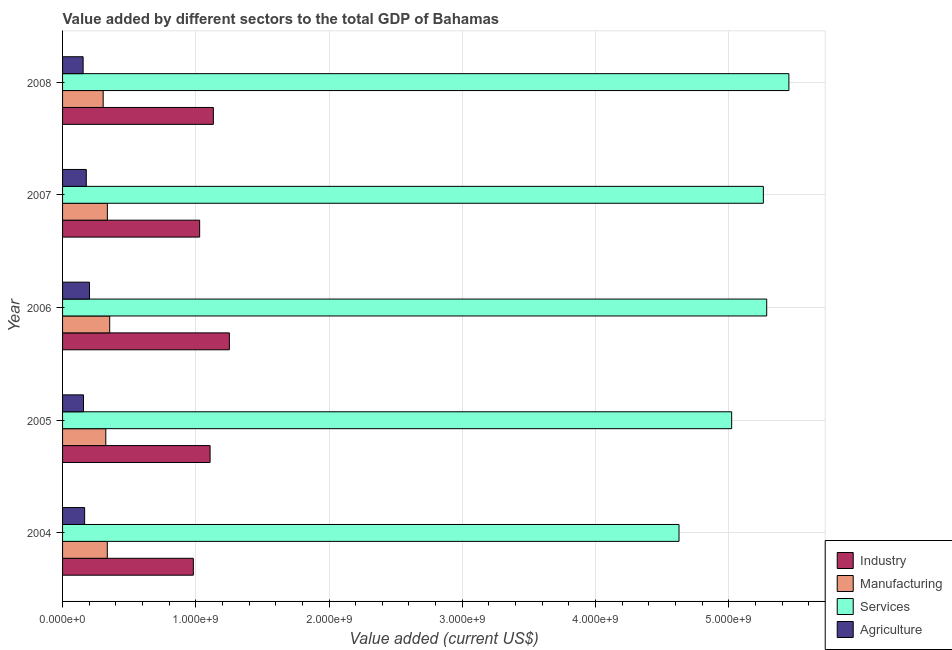How many groups of bars are there?
Your answer should be compact. 5. Are the number of bars per tick equal to the number of legend labels?
Provide a short and direct response. Yes. Are the number of bars on each tick of the Y-axis equal?
Offer a terse response. Yes. How many bars are there on the 3rd tick from the bottom?
Your answer should be very brief. 4. What is the label of the 2nd group of bars from the top?
Keep it short and to the point. 2007. In how many cases, is the number of bars for a given year not equal to the number of legend labels?
Give a very brief answer. 0. What is the value added by industrial sector in 2006?
Provide a succinct answer. 1.25e+09. Across all years, what is the maximum value added by industrial sector?
Your answer should be very brief. 1.25e+09. Across all years, what is the minimum value added by industrial sector?
Give a very brief answer. 9.82e+08. What is the total value added by manufacturing sector in the graph?
Provide a short and direct response. 1.66e+09. What is the difference between the value added by services sector in 2006 and that in 2008?
Keep it short and to the point. -1.67e+08. What is the difference between the value added by agricultural sector in 2004 and the value added by industrial sector in 2007?
Your answer should be very brief. -8.63e+08. What is the average value added by manufacturing sector per year?
Your response must be concise. 3.31e+08. In the year 2005, what is the difference between the value added by services sector and value added by manufacturing sector?
Your response must be concise. 4.70e+09. Is the difference between the value added by manufacturing sector in 2004 and 2008 greater than the difference between the value added by agricultural sector in 2004 and 2008?
Your answer should be very brief. Yes. What is the difference between the highest and the second highest value added by services sector?
Make the answer very short. 1.67e+08. What is the difference between the highest and the lowest value added by manufacturing sector?
Your answer should be very brief. 4.90e+07. Is the sum of the value added by manufacturing sector in 2005 and 2007 greater than the maximum value added by agricultural sector across all years?
Offer a terse response. Yes. What does the 2nd bar from the top in 2004 represents?
Give a very brief answer. Services. What does the 2nd bar from the bottom in 2004 represents?
Your answer should be compact. Manufacturing. Is it the case that in every year, the sum of the value added by industrial sector and value added by manufacturing sector is greater than the value added by services sector?
Offer a very short reply. No. Are the values on the major ticks of X-axis written in scientific E-notation?
Give a very brief answer. Yes. Does the graph contain grids?
Your answer should be compact. Yes. How many legend labels are there?
Give a very brief answer. 4. What is the title of the graph?
Provide a succinct answer. Value added by different sectors to the total GDP of Bahamas. What is the label or title of the X-axis?
Ensure brevity in your answer.  Value added (current US$). What is the label or title of the Y-axis?
Your answer should be compact. Year. What is the Value added (current US$) of Industry in 2004?
Provide a succinct answer. 9.82e+08. What is the Value added (current US$) in Manufacturing in 2004?
Your response must be concise. 3.36e+08. What is the Value added (current US$) of Services in 2004?
Ensure brevity in your answer.  4.63e+09. What is the Value added (current US$) in Agriculture in 2004?
Give a very brief answer. 1.66e+08. What is the Value added (current US$) of Industry in 2005?
Ensure brevity in your answer.  1.11e+09. What is the Value added (current US$) in Manufacturing in 2005?
Offer a very short reply. 3.25e+08. What is the Value added (current US$) of Services in 2005?
Your answer should be compact. 5.02e+09. What is the Value added (current US$) of Agriculture in 2005?
Your response must be concise. 1.57e+08. What is the Value added (current US$) of Industry in 2006?
Keep it short and to the point. 1.25e+09. What is the Value added (current US$) in Manufacturing in 2006?
Your response must be concise. 3.54e+08. What is the Value added (current US$) in Services in 2006?
Ensure brevity in your answer.  5.28e+09. What is the Value added (current US$) in Agriculture in 2006?
Provide a succinct answer. 2.02e+08. What is the Value added (current US$) of Industry in 2007?
Give a very brief answer. 1.03e+09. What is the Value added (current US$) of Manufacturing in 2007?
Keep it short and to the point. 3.36e+08. What is the Value added (current US$) in Services in 2007?
Provide a succinct answer. 5.26e+09. What is the Value added (current US$) in Agriculture in 2007?
Give a very brief answer. 1.78e+08. What is the Value added (current US$) of Industry in 2008?
Your answer should be compact. 1.13e+09. What is the Value added (current US$) of Manufacturing in 2008?
Ensure brevity in your answer.  3.05e+08. What is the Value added (current US$) in Services in 2008?
Offer a terse response. 5.45e+09. What is the Value added (current US$) in Agriculture in 2008?
Your answer should be very brief. 1.54e+08. Across all years, what is the maximum Value added (current US$) in Industry?
Offer a very short reply. 1.25e+09. Across all years, what is the maximum Value added (current US$) of Manufacturing?
Provide a short and direct response. 3.54e+08. Across all years, what is the maximum Value added (current US$) in Services?
Your response must be concise. 5.45e+09. Across all years, what is the maximum Value added (current US$) in Agriculture?
Your response must be concise. 2.02e+08. Across all years, what is the minimum Value added (current US$) of Industry?
Your response must be concise. 9.82e+08. Across all years, what is the minimum Value added (current US$) in Manufacturing?
Keep it short and to the point. 3.05e+08. Across all years, what is the minimum Value added (current US$) in Services?
Provide a succinct answer. 4.63e+09. Across all years, what is the minimum Value added (current US$) of Agriculture?
Make the answer very short. 1.54e+08. What is the total Value added (current US$) in Industry in the graph?
Your response must be concise. 5.50e+09. What is the total Value added (current US$) of Manufacturing in the graph?
Make the answer very short. 1.66e+09. What is the total Value added (current US$) of Services in the graph?
Give a very brief answer. 2.56e+1. What is the total Value added (current US$) of Agriculture in the graph?
Give a very brief answer. 8.57e+08. What is the difference between the Value added (current US$) of Industry in 2004 and that in 2005?
Ensure brevity in your answer.  -1.26e+08. What is the difference between the Value added (current US$) in Manufacturing in 2004 and that in 2005?
Your answer should be compact. 1.11e+07. What is the difference between the Value added (current US$) of Services in 2004 and that in 2005?
Give a very brief answer. -3.95e+08. What is the difference between the Value added (current US$) of Agriculture in 2004 and that in 2005?
Ensure brevity in your answer.  8.59e+06. What is the difference between the Value added (current US$) in Industry in 2004 and that in 2006?
Provide a succinct answer. -2.71e+08. What is the difference between the Value added (current US$) in Manufacturing in 2004 and that in 2006?
Keep it short and to the point. -1.81e+07. What is the difference between the Value added (current US$) in Services in 2004 and that in 2006?
Your response must be concise. -6.58e+08. What is the difference between the Value added (current US$) of Agriculture in 2004 and that in 2006?
Make the answer very short. -3.62e+07. What is the difference between the Value added (current US$) of Industry in 2004 and that in 2007?
Offer a terse response. -4.74e+07. What is the difference between the Value added (current US$) in Manufacturing in 2004 and that in 2007?
Your answer should be very brief. -5.55e+05. What is the difference between the Value added (current US$) in Services in 2004 and that in 2007?
Offer a very short reply. -6.33e+08. What is the difference between the Value added (current US$) in Agriculture in 2004 and that in 2007?
Your answer should be very brief. -1.24e+07. What is the difference between the Value added (current US$) of Industry in 2004 and that in 2008?
Offer a terse response. -1.50e+08. What is the difference between the Value added (current US$) of Manufacturing in 2004 and that in 2008?
Your answer should be compact. 3.09e+07. What is the difference between the Value added (current US$) in Services in 2004 and that in 2008?
Give a very brief answer. -8.25e+08. What is the difference between the Value added (current US$) in Agriculture in 2004 and that in 2008?
Ensure brevity in your answer.  1.13e+07. What is the difference between the Value added (current US$) in Industry in 2005 and that in 2006?
Make the answer very short. -1.45e+08. What is the difference between the Value added (current US$) of Manufacturing in 2005 and that in 2006?
Provide a short and direct response. -2.92e+07. What is the difference between the Value added (current US$) of Services in 2005 and that in 2006?
Keep it short and to the point. -2.63e+08. What is the difference between the Value added (current US$) of Agriculture in 2005 and that in 2006?
Provide a short and direct response. -4.48e+07. What is the difference between the Value added (current US$) of Industry in 2005 and that in 2007?
Your response must be concise. 7.83e+07. What is the difference between the Value added (current US$) in Manufacturing in 2005 and that in 2007?
Provide a succinct answer. -1.17e+07. What is the difference between the Value added (current US$) of Services in 2005 and that in 2007?
Ensure brevity in your answer.  -2.38e+08. What is the difference between the Value added (current US$) in Agriculture in 2005 and that in 2007?
Give a very brief answer. -2.09e+07. What is the difference between the Value added (current US$) in Industry in 2005 and that in 2008?
Your response must be concise. -2.46e+07. What is the difference between the Value added (current US$) of Manufacturing in 2005 and that in 2008?
Provide a succinct answer. 1.98e+07. What is the difference between the Value added (current US$) in Services in 2005 and that in 2008?
Offer a terse response. -4.30e+08. What is the difference between the Value added (current US$) in Agriculture in 2005 and that in 2008?
Offer a terse response. 2.76e+06. What is the difference between the Value added (current US$) in Industry in 2006 and that in 2007?
Offer a terse response. 2.23e+08. What is the difference between the Value added (current US$) of Manufacturing in 2006 and that in 2007?
Provide a succinct answer. 1.76e+07. What is the difference between the Value added (current US$) of Services in 2006 and that in 2007?
Your answer should be very brief. 2.51e+07. What is the difference between the Value added (current US$) in Agriculture in 2006 and that in 2007?
Provide a short and direct response. 2.38e+07. What is the difference between the Value added (current US$) of Industry in 2006 and that in 2008?
Your response must be concise. 1.20e+08. What is the difference between the Value added (current US$) of Manufacturing in 2006 and that in 2008?
Ensure brevity in your answer.  4.90e+07. What is the difference between the Value added (current US$) in Services in 2006 and that in 2008?
Make the answer very short. -1.67e+08. What is the difference between the Value added (current US$) in Agriculture in 2006 and that in 2008?
Ensure brevity in your answer.  4.75e+07. What is the difference between the Value added (current US$) in Industry in 2007 and that in 2008?
Make the answer very short. -1.03e+08. What is the difference between the Value added (current US$) of Manufacturing in 2007 and that in 2008?
Make the answer very short. 3.15e+07. What is the difference between the Value added (current US$) of Services in 2007 and that in 2008?
Ensure brevity in your answer.  -1.92e+08. What is the difference between the Value added (current US$) of Agriculture in 2007 and that in 2008?
Your response must be concise. 2.37e+07. What is the difference between the Value added (current US$) of Industry in 2004 and the Value added (current US$) of Manufacturing in 2005?
Your answer should be compact. 6.57e+08. What is the difference between the Value added (current US$) of Industry in 2004 and the Value added (current US$) of Services in 2005?
Offer a very short reply. -4.04e+09. What is the difference between the Value added (current US$) in Industry in 2004 and the Value added (current US$) in Agriculture in 2005?
Offer a very short reply. 8.24e+08. What is the difference between the Value added (current US$) of Manufacturing in 2004 and the Value added (current US$) of Services in 2005?
Provide a succinct answer. -4.69e+09. What is the difference between the Value added (current US$) in Manufacturing in 2004 and the Value added (current US$) in Agriculture in 2005?
Offer a terse response. 1.79e+08. What is the difference between the Value added (current US$) in Services in 2004 and the Value added (current US$) in Agriculture in 2005?
Keep it short and to the point. 4.47e+09. What is the difference between the Value added (current US$) in Industry in 2004 and the Value added (current US$) in Manufacturing in 2006?
Give a very brief answer. 6.28e+08. What is the difference between the Value added (current US$) of Industry in 2004 and the Value added (current US$) of Services in 2006?
Keep it short and to the point. -4.30e+09. What is the difference between the Value added (current US$) in Industry in 2004 and the Value added (current US$) in Agriculture in 2006?
Provide a short and direct response. 7.80e+08. What is the difference between the Value added (current US$) of Manufacturing in 2004 and the Value added (current US$) of Services in 2006?
Keep it short and to the point. -4.95e+09. What is the difference between the Value added (current US$) of Manufacturing in 2004 and the Value added (current US$) of Agriculture in 2006?
Ensure brevity in your answer.  1.34e+08. What is the difference between the Value added (current US$) of Services in 2004 and the Value added (current US$) of Agriculture in 2006?
Offer a very short reply. 4.42e+09. What is the difference between the Value added (current US$) of Industry in 2004 and the Value added (current US$) of Manufacturing in 2007?
Provide a succinct answer. 6.45e+08. What is the difference between the Value added (current US$) of Industry in 2004 and the Value added (current US$) of Services in 2007?
Your response must be concise. -4.28e+09. What is the difference between the Value added (current US$) of Industry in 2004 and the Value added (current US$) of Agriculture in 2007?
Your answer should be very brief. 8.04e+08. What is the difference between the Value added (current US$) of Manufacturing in 2004 and the Value added (current US$) of Services in 2007?
Provide a succinct answer. -4.92e+09. What is the difference between the Value added (current US$) in Manufacturing in 2004 and the Value added (current US$) in Agriculture in 2007?
Ensure brevity in your answer.  1.58e+08. What is the difference between the Value added (current US$) of Services in 2004 and the Value added (current US$) of Agriculture in 2007?
Your response must be concise. 4.45e+09. What is the difference between the Value added (current US$) in Industry in 2004 and the Value added (current US$) in Manufacturing in 2008?
Offer a terse response. 6.77e+08. What is the difference between the Value added (current US$) in Industry in 2004 and the Value added (current US$) in Services in 2008?
Make the answer very short. -4.47e+09. What is the difference between the Value added (current US$) of Industry in 2004 and the Value added (current US$) of Agriculture in 2008?
Provide a short and direct response. 8.27e+08. What is the difference between the Value added (current US$) in Manufacturing in 2004 and the Value added (current US$) in Services in 2008?
Provide a short and direct response. -5.12e+09. What is the difference between the Value added (current US$) in Manufacturing in 2004 and the Value added (current US$) in Agriculture in 2008?
Your answer should be very brief. 1.81e+08. What is the difference between the Value added (current US$) in Services in 2004 and the Value added (current US$) in Agriculture in 2008?
Keep it short and to the point. 4.47e+09. What is the difference between the Value added (current US$) in Industry in 2005 and the Value added (current US$) in Manufacturing in 2006?
Ensure brevity in your answer.  7.53e+08. What is the difference between the Value added (current US$) of Industry in 2005 and the Value added (current US$) of Services in 2006?
Keep it short and to the point. -4.18e+09. What is the difference between the Value added (current US$) of Industry in 2005 and the Value added (current US$) of Agriculture in 2006?
Offer a terse response. 9.05e+08. What is the difference between the Value added (current US$) in Manufacturing in 2005 and the Value added (current US$) in Services in 2006?
Offer a very short reply. -4.96e+09. What is the difference between the Value added (current US$) in Manufacturing in 2005 and the Value added (current US$) in Agriculture in 2006?
Your answer should be compact. 1.23e+08. What is the difference between the Value added (current US$) of Services in 2005 and the Value added (current US$) of Agriculture in 2006?
Your answer should be very brief. 4.82e+09. What is the difference between the Value added (current US$) in Industry in 2005 and the Value added (current US$) in Manufacturing in 2007?
Your answer should be very brief. 7.71e+08. What is the difference between the Value added (current US$) of Industry in 2005 and the Value added (current US$) of Services in 2007?
Ensure brevity in your answer.  -4.15e+09. What is the difference between the Value added (current US$) of Industry in 2005 and the Value added (current US$) of Agriculture in 2007?
Give a very brief answer. 9.29e+08. What is the difference between the Value added (current US$) of Manufacturing in 2005 and the Value added (current US$) of Services in 2007?
Make the answer very short. -4.94e+09. What is the difference between the Value added (current US$) of Manufacturing in 2005 and the Value added (current US$) of Agriculture in 2007?
Make the answer very short. 1.47e+08. What is the difference between the Value added (current US$) of Services in 2005 and the Value added (current US$) of Agriculture in 2007?
Your answer should be compact. 4.84e+09. What is the difference between the Value added (current US$) of Industry in 2005 and the Value added (current US$) of Manufacturing in 2008?
Keep it short and to the point. 8.02e+08. What is the difference between the Value added (current US$) in Industry in 2005 and the Value added (current US$) in Services in 2008?
Make the answer very short. -4.34e+09. What is the difference between the Value added (current US$) in Industry in 2005 and the Value added (current US$) in Agriculture in 2008?
Offer a very short reply. 9.53e+08. What is the difference between the Value added (current US$) of Manufacturing in 2005 and the Value added (current US$) of Services in 2008?
Your response must be concise. -5.13e+09. What is the difference between the Value added (current US$) of Manufacturing in 2005 and the Value added (current US$) of Agriculture in 2008?
Your answer should be very brief. 1.70e+08. What is the difference between the Value added (current US$) of Services in 2005 and the Value added (current US$) of Agriculture in 2008?
Provide a succinct answer. 4.87e+09. What is the difference between the Value added (current US$) of Industry in 2006 and the Value added (current US$) of Manufacturing in 2007?
Your response must be concise. 9.16e+08. What is the difference between the Value added (current US$) in Industry in 2006 and the Value added (current US$) in Services in 2007?
Offer a very short reply. -4.01e+09. What is the difference between the Value added (current US$) of Industry in 2006 and the Value added (current US$) of Agriculture in 2007?
Offer a terse response. 1.07e+09. What is the difference between the Value added (current US$) of Manufacturing in 2006 and the Value added (current US$) of Services in 2007?
Your answer should be very brief. -4.91e+09. What is the difference between the Value added (current US$) of Manufacturing in 2006 and the Value added (current US$) of Agriculture in 2007?
Your answer should be very brief. 1.76e+08. What is the difference between the Value added (current US$) in Services in 2006 and the Value added (current US$) in Agriculture in 2007?
Ensure brevity in your answer.  5.11e+09. What is the difference between the Value added (current US$) in Industry in 2006 and the Value added (current US$) in Manufacturing in 2008?
Give a very brief answer. 9.47e+08. What is the difference between the Value added (current US$) in Industry in 2006 and the Value added (current US$) in Services in 2008?
Make the answer very short. -4.20e+09. What is the difference between the Value added (current US$) in Industry in 2006 and the Value added (current US$) in Agriculture in 2008?
Your answer should be compact. 1.10e+09. What is the difference between the Value added (current US$) of Manufacturing in 2006 and the Value added (current US$) of Services in 2008?
Offer a very short reply. -5.10e+09. What is the difference between the Value added (current US$) in Manufacturing in 2006 and the Value added (current US$) in Agriculture in 2008?
Keep it short and to the point. 1.99e+08. What is the difference between the Value added (current US$) in Services in 2006 and the Value added (current US$) in Agriculture in 2008?
Your answer should be compact. 5.13e+09. What is the difference between the Value added (current US$) of Industry in 2007 and the Value added (current US$) of Manufacturing in 2008?
Make the answer very short. 7.24e+08. What is the difference between the Value added (current US$) of Industry in 2007 and the Value added (current US$) of Services in 2008?
Your answer should be very brief. -4.42e+09. What is the difference between the Value added (current US$) in Industry in 2007 and the Value added (current US$) in Agriculture in 2008?
Provide a short and direct response. 8.75e+08. What is the difference between the Value added (current US$) in Manufacturing in 2007 and the Value added (current US$) in Services in 2008?
Give a very brief answer. -5.12e+09. What is the difference between the Value added (current US$) of Manufacturing in 2007 and the Value added (current US$) of Agriculture in 2008?
Ensure brevity in your answer.  1.82e+08. What is the difference between the Value added (current US$) of Services in 2007 and the Value added (current US$) of Agriculture in 2008?
Ensure brevity in your answer.  5.11e+09. What is the average Value added (current US$) of Industry per year?
Your response must be concise. 1.10e+09. What is the average Value added (current US$) in Manufacturing per year?
Ensure brevity in your answer.  3.31e+08. What is the average Value added (current US$) in Services per year?
Your response must be concise. 5.13e+09. What is the average Value added (current US$) of Agriculture per year?
Offer a very short reply. 1.71e+08. In the year 2004, what is the difference between the Value added (current US$) in Industry and Value added (current US$) in Manufacturing?
Offer a terse response. 6.46e+08. In the year 2004, what is the difference between the Value added (current US$) in Industry and Value added (current US$) in Services?
Keep it short and to the point. -3.65e+09. In the year 2004, what is the difference between the Value added (current US$) of Industry and Value added (current US$) of Agriculture?
Your answer should be very brief. 8.16e+08. In the year 2004, what is the difference between the Value added (current US$) in Manufacturing and Value added (current US$) in Services?
Provide a short and direct response. -4.29e+09. In the year 2004, what is the difference between the Value added (current US$) in Manufacturing and Value added (current US$) in Agriculture?
Give a very brief answer. 1.70e+08. In the year 2004, what is the difference between the Value added (current US$) in Services and Value added (current US$) in Agriculture?
Your answer should be very brief. 4.46e+09. In the year 2005, what is the difference between the Value added (current US$) in Industry and Value added (current US$) in Manufacturing?
Your answer should be compact. 7.83e+08. In the year 2005, what is the difference between the Value added (current US$) in Industry and Value added (current US$) in Services?
Your answer should be very brief. -3.91e+09. In the year 2005, what is the difference between the Value added (current US$) in Industry and Value added (current US$) in Agriculture?
Keep it short and to the point. 9.50e+08. In the year 2005, what is the difference between the Value added (current US$) of Manufacturing and Value added (current US$) of Services?
Your answer should be compact. -4.70e+09. In the year 2005, what is the difference between the Value added (current US$) in Manufacturing and Value added (current US$) in Agriculture?
Give a very brief answer. 1.67e+08. In the year 2005, what is the difference between the Value added (current US$) of Services and Value added (current US$) of Agriculture?
Your response must be concise. 4.86e+09. In the year 2006, what is the difference between the Value added (current US$) in Industry and Value added (current US$) in Manufacturing?
Keep it short and to the point. 8.98e+08. In the year 2006, what is the difference between the Value added (current US$) of Industry and Value added (current US$) of Services?
Provide a succinct answer. -4.03e+09. In the year 2006, what is the difference between the Value added (current US$) in Industry and Value added (current US$) in Agriculture?
Give a very brief answer. 1.05e+09. In the year 2006, what is the difference between the Value added (current US$) of Manufacturing and Value added (current US$) of Services?
Make the answer very short. -4.93e+09. In the year 2006, what is the difference between the Value added (current US$) in Manufacturing and Value added (current US$) in Agriculture?
Your answer should be compact. 1.52e+08. In the year 2006, what is the difference between the Value added (current US$) of Services and Value added (current US$) of Agriculture?
Offer a terse response. 5.08e+09. In the year 2007, what is the difference between the Value added (current US$) in Industry and Value added (current US$) in Manufacturing?
Offer a terse response. 6.93e+08. In the year 2007, what is the difference between the Value added (current US$) of Industry and Value added (current US$) of Services?
Make the answer very short. -4.23e+09. In the year 2007, what is the difference between the Value added (current US$) of Industry and Value added (current US$) of Agriculture?
Provide a short and direct response. 8.51e+08. In the year 2007, what is the difference between the Value added (current US$) of Manufacturing and Value added (current US$) of Services?
Ensure brevity in your answer.  -4.92e+09. In the year 2007, what is the difference between the Value added (current US$) in Manufacturing and Value added (current US$) in Agriculture?
Offer a very short reply. 1.58e+08. In the year 2007, what is the difference between the Value added (current US$) in Services and Value added (current US$) in Agriculture?
Offer a very short reply. 5.08e+09. In the year 2008, what is the difference between the Value added (current US$) in Industry and Value added (current US$) in Manufacturing?
Offer a very short reply. 8.27e+08. In the year 2008, what is the difference between the Value added (current US$) in Industry and Value added (current US$) in Services?
Provide a short and direct response. -4.32e+09. In the year 2008, what is the difference between the Value added (current US$) of Industry and Value added (current US$) of Agriculture?
Keep it short and to the point. 9.78e+08. In the year 2008, what is the difference between the Value added (current US$) of Manufacturing and Value added (current US$) of Services?
Your answer should be compact. -5.15e+09. In the year 2008, what is the difference between the Value added (current US$) in Manufacturing and Value added (current US$) in Agriculture?
Offer a very short reply. 1.50e+08. In the year 2008, what is the difference between the Value added (current US$) of Services and Value added (current US$) of Agriculture?
Offer a very short reply. 5.30e+09. What is the ratio of the Value added (current US$) of Industry in 2004 to that in 2005?
Offer a terse response. 0.89. What is the ratio of the Value added (current US$) in Manufacturing in 2004 to that in 2005?
Offer a terse response. 1.03. What is the ratio of the Value added (current US$) in Services in 2004 to that in 2005?
Keep it short and to the point. 0.92. What is the ratio of the Value added (current US$) of Agriculture in 2004 to that in 2005?
Your response must be concise. 1.05. What is the ratio of the Value added (current US$) of Industry in 2004 to that in 2006?
Make the answer very short. 0.78. What is the ratio of the Value added (current US$) of Manufacturing in 2004 to that in 2006?
Keep it short and to the point. 0.95. What is the ratio of the Value added (current US$) in Services in 2004 to that in 2006?
Ensure brevity in your answer.  0.88. What is the ratio of the Value added (current US$) in Agriculture in 2004 to that in 2006?
Make the answer very short. 0.82. What is the ratio of the Value added (current US$) of Industry in 2004 to that in 2007?
Ensure brevity in your answer.  0.95. What is the ratio of the Value added (current US$) of Manufacturing in 2004 to that in 2007?
Offer a terse response. 1. What is the ratio of the Value added (current US$) in Services in 2004 to that in 2007?
Your answer should be compact. 0.88. What is the ratio of the Value added (current US$) of Agriculture in 2004 to that in 2007?
Ensure brevity in your answer.  0.93. What is the ratio of the Value added (current US$) in Industry in 2004 to that in 2008?
Your response must be concise. 0.87. What is the ratio of the Value added (current US$) of Manufacturing in 2004 to that in 2008?
Provide a succinct answer. 1.1. What is the ratio of the Value added (current US$) of Services in 2004 to that in 2008?
Your answer should be compact. 0.85. What is the ratio of the Value added (current US$) in Agriculture in 2004 to that in 2008?
Provide a short and direct response. 1.07. What is the ratio of the Value added (current US$) in Industry in 2005 to that in 2006?
Offer a very short reply. 0.88. What is the ratio of the Value added (current US$) in Manufacturing in 2005 to that in 2006?
Provide a succinct answer. 0.92. What is the ratio of the Value added (current US$) of Services in 2005 to that in 2006?
Ensure brevity in your answer.  0.95. What is the ratio of the Value added (current US$) of Agriculture in 2005 to that in 2006?
Your answer should be compact. 0.78. What is the ratio of the Value added (current US$) in Industry in 2005 to that in 2007?
Provide a succinct answer. 1.08. What is the ratio of the Value added (current US$) in Manufacturing in 2005 to that in 2007?
Give a very brief answer. 0.97. What is the ratio of the Value added (current US$) of Services in 2005 to that in 2007?
Make the answer very short. 0.95. What is the ratio of the Value added (current US$) of Agriculture in 2005 to that in 2007?
Your response must be concise. 0.88. What is the ratio of the Value added (current US$) of Industry in 2005 to that in 2008?
Your answer should be very brief. 0.98. What is the ratio of the Value added (current US$) of Manufacturing in 2005 to that in 2008?
Your response must be concise. 1.06. What is the ratio of the Value added (current US$) in Services in 2005 to that in 2008?
Ensure brevity in your answer.  0.92. What is the ratio of the Value added (current US$) in Agriculture in 2005 to that in 2008?
Keep it short and to the point. 1.02. What is the ratio of the Value added (current US$) in Industry in 2006 to that in 2007?
Ensure brevity in your answer.  1.22. What is the ratio of the Value added (current US$) in Manufacturing in 2006 to that in 2007?
Provide a succinct answer. 1.05. What is the ratio of the Value added (current US$) in Services in 2006 to that in 2007?
Your answer should be very brief. 1. What is the ratio of the Value added (current US$) of Agriculture in 2006 to that in 2007?
Provide a succinct answer. 1.13. What is the ratio of the Value added (current US$) of Industry in 2006 to that in 2008?
Your answer should be compact. 1.11. What is the ratio of the Value added (current US$) in Manufacturing in 2006 to that in 2008?
Provide a succinct answer. 1.16. What is the ratio of the Value added (current US$) of Services in 2006 to that in 2008?
Provide a short and direct response. 0.97. What is the ratio of the Value added (current US$) in Agriculture in 2006 to that in 2008?
Offer a very short reply. 1.31. What is the ratio of the Value added (current US$) in Industry in 2007 to that in 2008?
Keep it short and to the point. 0.91. What is the ratio of the Value added (current US$) in Manufacturing in 2007 to that in 2008?
Ensure brevity in your answer.  1.1. What is the ratio of the Value added (current US$) of Services in 2007 to that in 2008?
Your response must be concise. 0.96. What is the ratio of the Value added (current US$) of Agriculture in 2007 to that in 2008?
Keep it short and to the point. 1.15. What is the difference between the highest and the second highest Value added (current US$) of Industry?
Your answer should be compact. 1.20e+08. What is the difference between the highest and the second highest Value added (current US$) in Manufacturing?
Keep it short and to the point. 1.76e+07. What is the difference between the highest and the second highest Value added (current US$) in Services?
Ensure brevity in your answer.  1.67e+08. What is the difference between the highest and the second highest Value added (current US$) in Agriculture?
Offer a very short reply. 2.38e+07. What is the difference between the highest and the lowest Value added (current US$) of Industry?
Provide a short and direct response. 2.71e+08. What is the difference between the highest and the lowest Value added (current US$) of Manufacturing?
Provide a short and direct response. 4.90e+07. What is the difference between the highest and the lowest Value added (current US$) of Services?
Offer a very short reply. 8.25e+08. What is the difference between the highest and the lowest Value added (current US$) in Agriculture?
Give a very brief answer. 4.75e+07. 